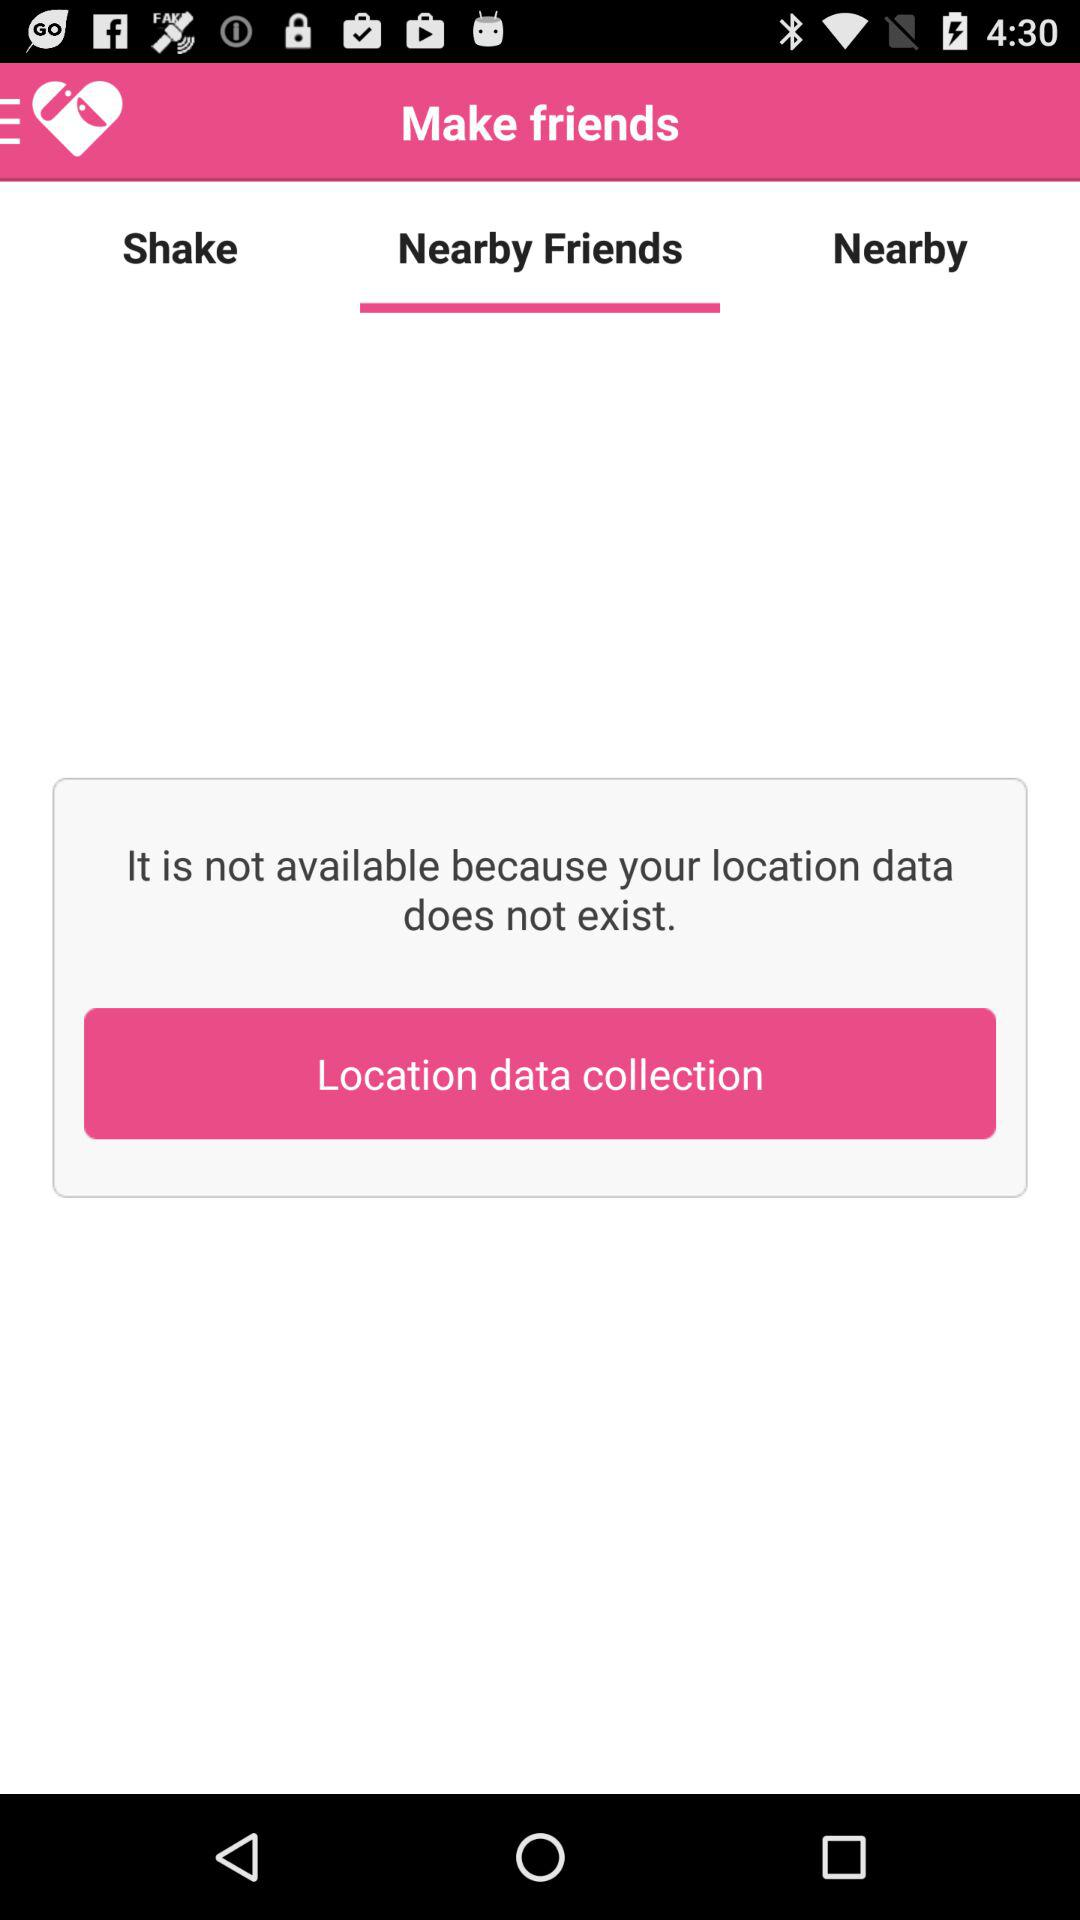What is the selected tab? The selected tab is "Nearby Friends". 